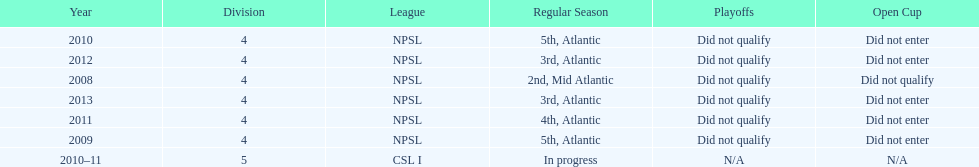What was the last year they came in 3rd place 2013. 